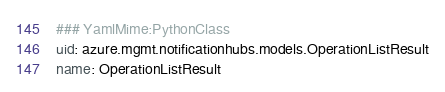<code> <loc_0><loc_0><loc_500><loc_500><_YAML_>### YamlMime:PythonClass
uid: azure.mgmt.notificationhubs.models.OperationListResult
name: OperationListResult</code> 